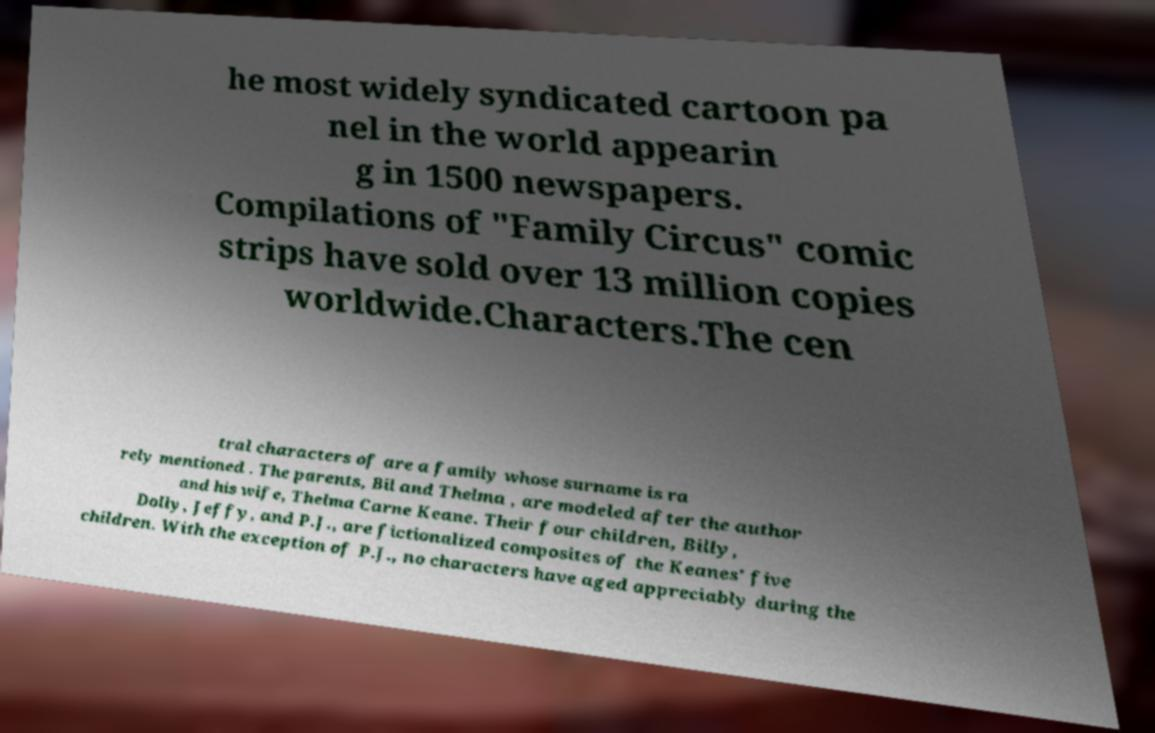Can you read and provide the text displayed in the image?This photo seems to have some interesting text. Can you extract and type it out for me? he most widely syndicated cartoon pa nel in the world appearin g in 1500 newspapers. Compilations of "Family Circus" comic strips have sold over 13 million copies worldwide.Characters.The cen tral characters of are a family whose surname is ra rely mentioned . The parents, Bil and Thelma , are modeled after the author and his wife, Thelma Carne Keane. Their four children, Billy, Dolly, Jeffy, and P.J., are fictionalized composites of the Keanes' five children. With the exception of P.J., no characters have aged appreciably during the 